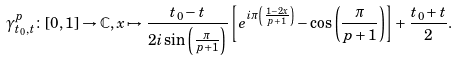Convert formula to latex. <formula><loc_0><loc_0><loc_500><loc_500>\gamma ^ { p } _ { t _ { 0 } , t } \colon [ 0 , 1 ] \to \mathbb { C } , x \mapsto \frac { t _ { 0 } - t } { 2 i \sin \left ( \frac { \pi } { p + 1 } \right ) } \left [ e ^ { i \pi \left ( \frac { 1 - 2 x } { p + 1 } \right ) } - \cos \left ( \frac { \pi } { p + 1 } \right ) \right ] + \frac { t _ { 0 } + t } { 2 } .</formula> 